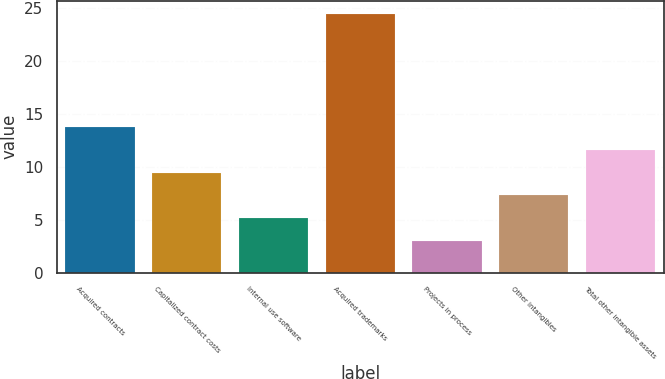Convert chart. <chart><loc_0><loc_0><loc_500><loc_500><bar_chart><fcel>Acquired contracts<fcel>Capitalized contract costs<fcel>Internal use software<fcel>Acquired trademarks<fcel>Projects in process<fcel>Other intangibles<fcel>Total other intangible assets<nl><fcel>13.75<fcel>9.45<fcel>5.15<fcel>24.5<fcel>3<fcel>7.3<fcel>11.6<nl></chart> 